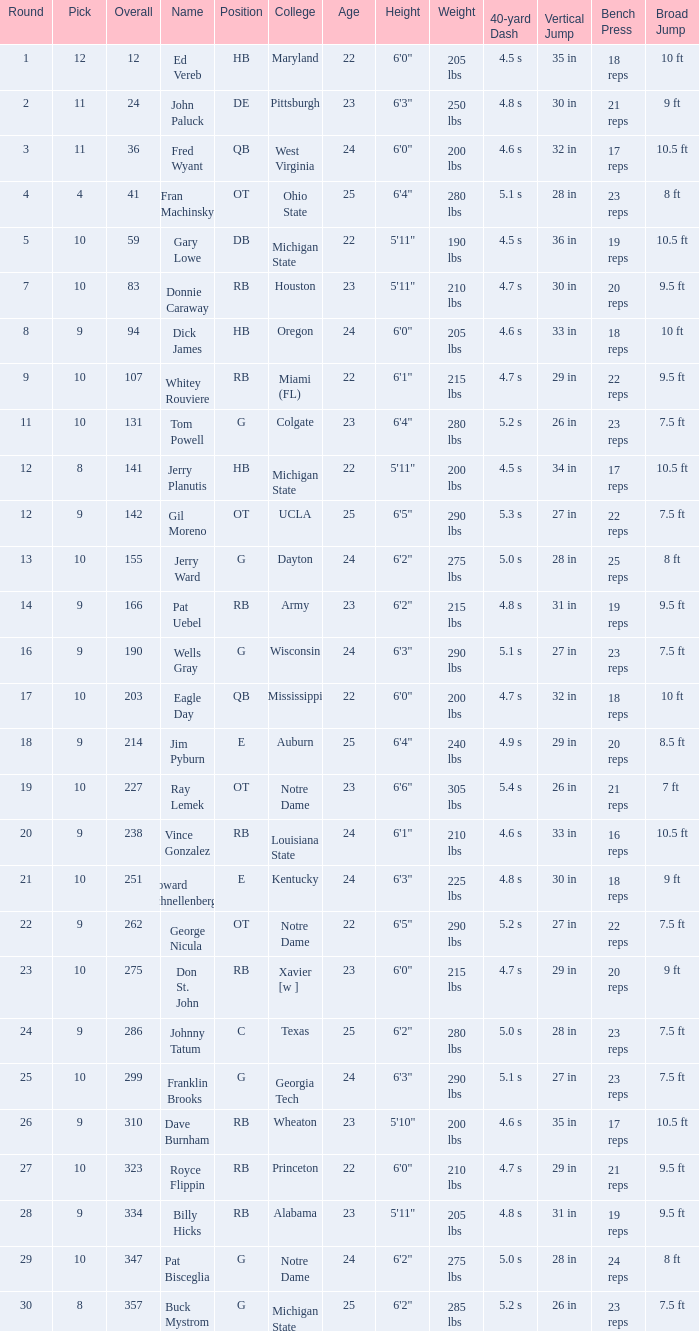What is the sum of rounds that has a pick of 9 and is named jim pyburn? 18.0. 